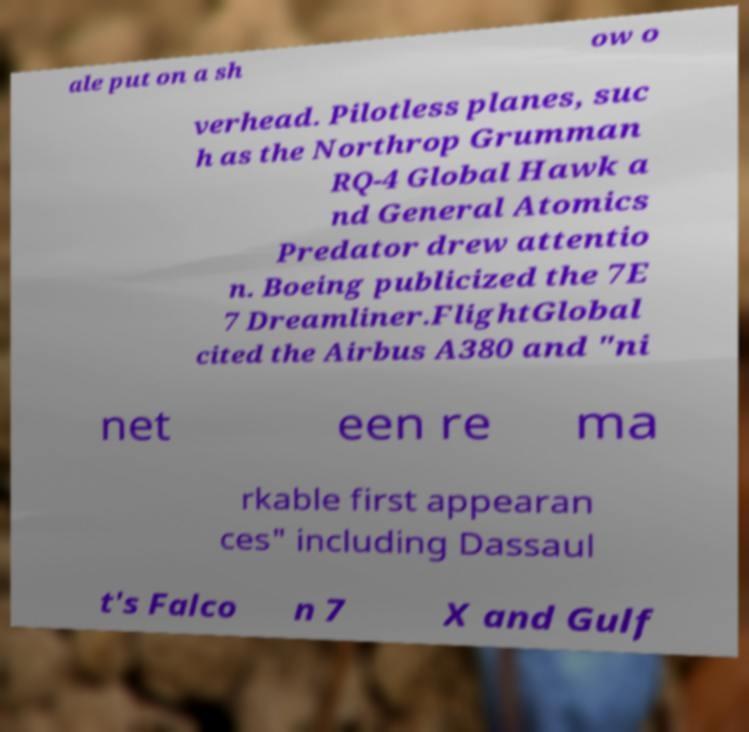There's text embedded in this image that I need extracted. Can you transcribe it verbatim? ale put on a sh ow o verhead. Pilotless planes, suc h as the Northrop Grumman RQ-4 Global Hawk a nd General Atomics Predator drew attentio n. Boeing publicized the 7E 7 Dreamliner.FlightGlobal cited the Airbus A380 and "ni net een re ma rkable first appearan ces" including Dassaul t's Falco n 7 X and Gulf 